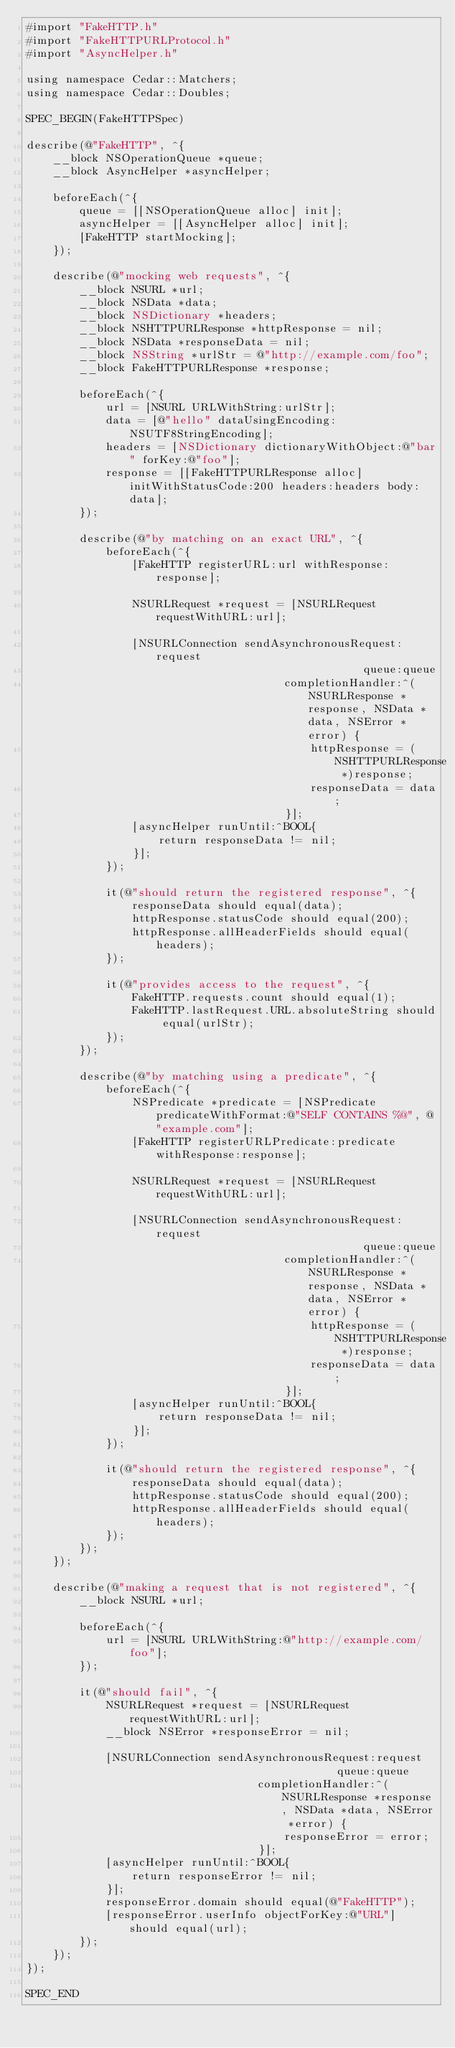Convert code to text. <code><loc_0><loc_0><loc_500><loc_500><_ObjectiveC_>#import "FakeHTTP.h"
#import "FakeHTTPURLProtocol.h"
#import "AsyncHelper.h"

using namespace Cedar::Matchers;
using namespace Cedar::Doubles;

SPEC_BEGIN(FakeHTTPSpec)

describe(@"FakeHTTP", ^{
    __block NSOperationQueue *queue;
    __block AsyncHelper *asyncHelper;
    
    beforeEach(^{
        queue = [[NSOperationQueue alloc] init];
        asyncHelper = [[AsyncHelper alloc] init];
        [FakeHTTP startMocking];
    });
    
    describe(@"mocking web requests", ^{
        __block NSURL *url;
        __block NSData *data;
        __block NSDictionary *headers;
        __block NSHTTPURLResponse *httpResponse = nil;
        __block NSData *responseData = nil;
        __block NSString *urlStr = @"http://example.com/foo";
        __block FakeHTTPURLResponse *response;

        beforeEach(^{
            url = [NSURL URLWithString:urlStr];
            data = [@"hello" dataUsingEncoding:NSUTF8StringEncoding];
            headers = [NSDictionary dictionaryWithObject:@"bar" forKey:@"foo"];
            response = [[FakeHTTPURLResponse alloc] initWithStatusCode:200 headers:headers body:data];
        });

        describe(@"by matching on an exact URL", ^{
            beforeEach(^{
                [FakeHTTP registerURL:url withResponse:response];

                NSURLRequest *request = [NSURLRequest requestWithURL:url];

                [NSURLConnection sendAsynchronousRequest:request
                                                   queue:queue
                                       completionHandler:^(NSURLResponse *response, NSData *data, NSError *error) {
                                           httpResponse = (NSHTTPURLResponse *)response;
                                           responseData = data;
                                       }];
                [asyncHelper runUntil:^BOOL{
                    return responseData != nil;
                }];
            });

            it(@"should return the registered response", ^{
                responseData should equal(data);
                httpResponse.statusCode should equal(200);
                httpResponse.allHeaderFields should equal(headers);
            });

            it(@"provides access to the request", ^{
                FakeHTTP.requests.count should equal(1);
                FakeHTTP.lastRequest.URL.absoluteString should equal(urlStr);
            });
        });

        describe(@"by matching using a predicate", ^{
            beforeEach(^{
                NSPredicate *predicate = [NSPredicate predicateWithFormat:@"SELF CONTAINS %@", @"example.com"];
                [FakeHTTP registerURLPredicate:predicate withResponse:response];

                NSURLRequest *request = [NSURLRequest requestWithURL:url];

                [NSURLConnection sendAsynchronousRequest:request
                                                   queue:queue
                                       completionHandler:^(NSURLResponse *response, NSData *data, NSError *error) {
                                           httpResponse = (NSHTTPURLResponse *)response;
                                           responseData = data;
                                       }];
                [asyncHelper runUntil:^BOOL{
                    return responseData != nil;
                }];
            });

            it(@"should return the registered response", ^{
                responseData should equal(data);
                httpResponse.statusCode should equal(200);
                httpResponse.allHeaderFields should equal(headers);
            });
        });
    });

    describe(@"making a request that is not registered", ^{
        __block NSURL *url;
        
        beforeEach(^{
            url = [NSURL URLWithString:@"http://example.com/foo"];
        });
        
        it(@"should fail", ^{
            NSURLRequest *request = [NSURLRequest requestWithURL:url];
            __block NSError *responseError = nil;
            
            [NSURLConnection sendAsynchronousRequest:request
                                               queue:queue
                                   completionHandler:^(NSURLResponse *response, NSData *data, NSError *error) {
                                       responseError = error;
                                   }];
            [asyncHelper runUntil:^BOOL{
                return responseError != nil;
            }];
            responseError.domain should equal(@"FakeHTTP");
            [responseError.userInfo objectForKey:@"URL"] should equal(url);
        });
    });
});

SPEC_END
</code> 